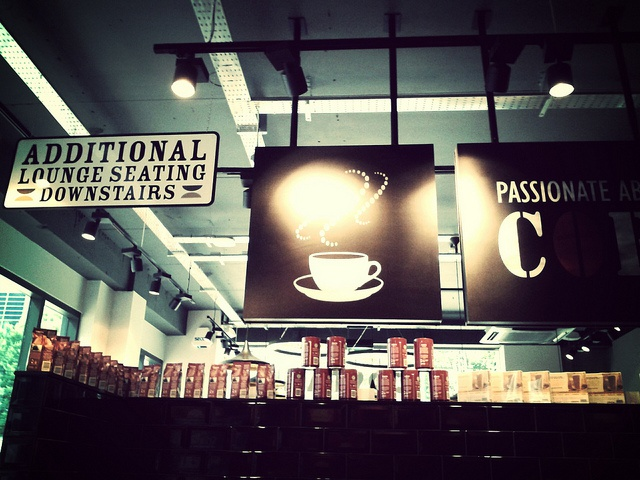Describe the objects in this image and their specific colors. I can see a cup in black, beige, tan, and brown tones in this image. 